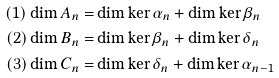<formula> <loc_0><loc_0><loc_500><loc_500>( 1 ) \dim A _ { n } = & \dim \ker \alpha _ { n } + \dim \ker \beta _ { n } \\ ( 2 ) \dim B _ { n } = & \dim \ker \beta _ { n } + \dim \ker \delta _ { n } \\ ( 3 ) \dim C _ { n } = & \dim \ker \delta _ { n } + \dim \ker \alpha _ { n - 1 }</formula> 